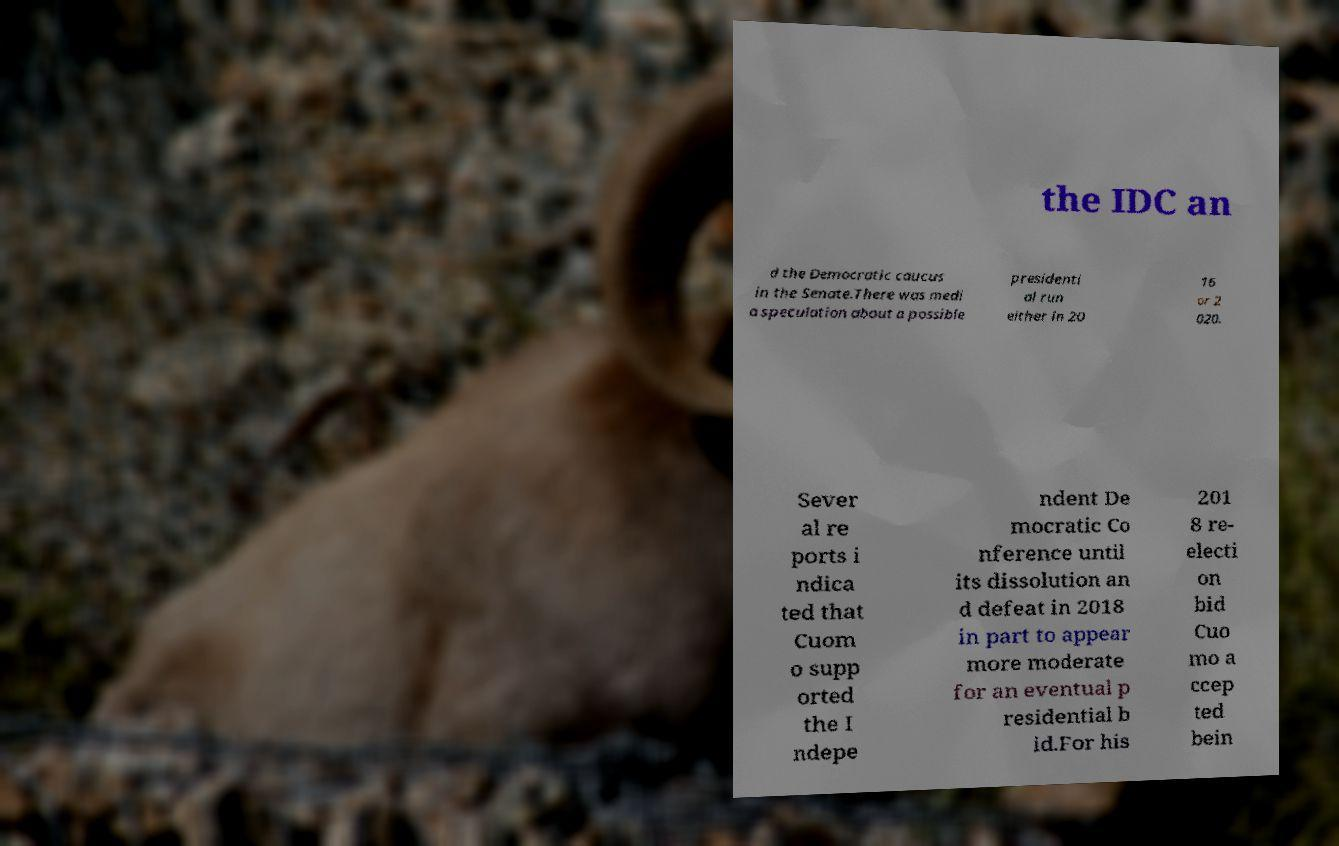Could you assist in decoding the text presented in this image and type it out clearly? the IDC an d the Democratic caucus in the Senate.There was medi a speculation about a possible presidenti al run either in 20 16 or 2 020. Sever al re ports i ndica ted that Cuom o supp orted the I ndepe ndent De mocratic Co nference until its dissolution an d defeat in 2018 in part to appear more moderate for an eventual p residential b id.For his 201 8 re- electi on bid Cuo mo a ccep ted bein 